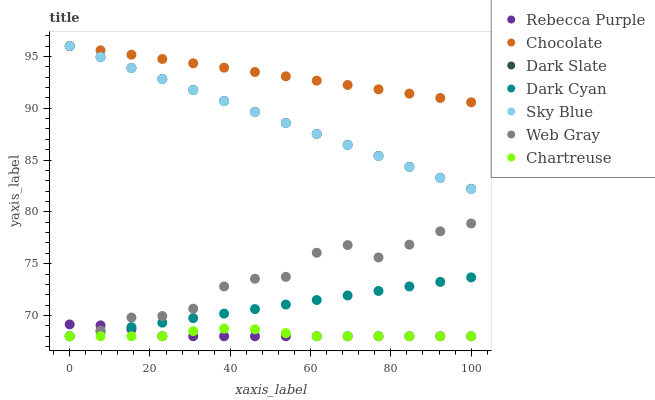Does Chartreuse have the minimum area under the curve?
Answer yes or no. Yes. Does Chocolate have the maximum area under the curve?
Answer yes or no. Yes. Does Dark Slate have the minimum area under the curve?
Answer yes or no. No. Does Dark Slate have the maximum area under the curve?
Answer yes or no. No. Is Chocolate the smoothest?
Answer yes or no. Yes. Is Web Gray the roughest?
Answer yes or no. Yes. Is Dark Slate the smoothest?
Answer yes or no. No. Is Dark Slate the roughest?
Answer yes or no. No. Does Web Gray have the lowest value?
Answer yes or no. Yes. Does Dark Slate have the lowest value?
Answer yes or no. No. Does Sky Blue have the highest value?
Answer yes or no. Yes. Does Chartreuse have the highest value?
Answer yes or no. No. Is Chartreuse less than Sky Blue?
Answer yes or no. Yes. Is Chocolate greater than Chartreuse?
Answer yes or no. Yes. Does Rebecca Purple intersect Dark Cyan?
Answer yes or no. Yes. Is Rebecca Purple less than Dark Cyan?
Answer yes or no. No. Is Rebecca Purple greater than Dark Cyan?
Answer yes or no. No. Does Chartreuse intersect Sky Blue?
Answer yes or no. No. 